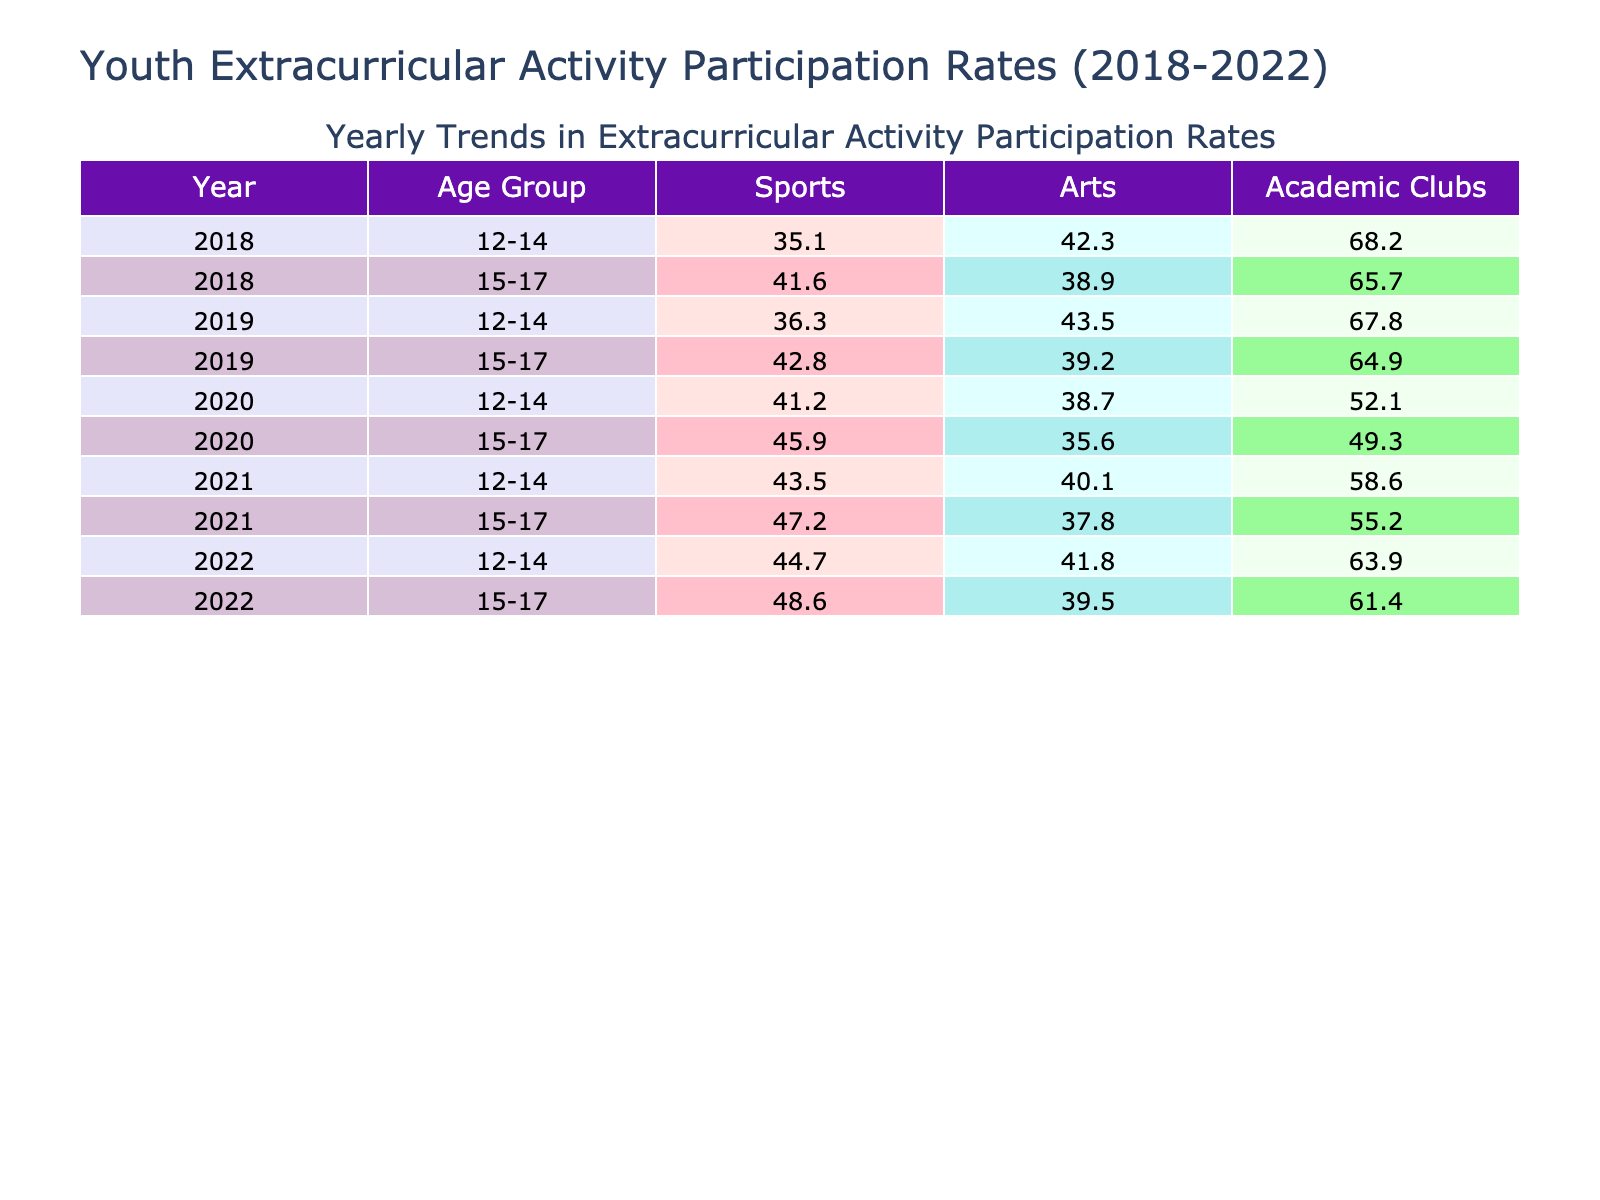What is the participation rate in sports for the age group 12-14 in 2019? In the table, we look for the row where the Year is 2019 and the Age Group is 12-14. The Participation Rate for Sports in that row is 67.8.
Answer: 67.8 What was the highest participation rate for arts among the age group 15-17 during the years 2018 to 2022? To find this, we check the Participation Rates for Arts for the age group 15-17 across all years. The rates are: 38.9 (2018), 39.2 (2019), 35.6 (2020), 37.8 (2021), and 39.5 (2022). The highest value is 39.5 in 2022.
Answer: 39.5 Which activity had the lowest average participation rate for the age group 12-14 across the years? We calculate the average Participation Rates for each activity for the age group 12-14: Sports (66.0), Arts (41.6), and Academic Clubs (38.3). The averages are Sports (66.0), Arts (41.6), Academic Clubs (38.3). The lowest average is for Academic Clubs.
Answer: Academic Clubs Did the participation rate in sports for the age group 15-17 increase from 2020 to 2022? The participation rate in sports for age group 15-17 was 49.3 in 2020 and increased to 61.4 in 2022. Therefore, it did increase between those years.
Answer: Yes Which age group and activity combination had the highest participation rate in 2021? In 2021, we need to find the maximum Participation Rate across all activities and age groups. The rates are: Sports (58.6 for 12-14 and 55.2 for 15-17), Arts (40.1 for 12-14 and 37.8 for 15-17), and Academic Clubs (43.5 for 12-14 and 47.2 for 15-17). The highest is Sports for the age group 12-14 with 58.6.
Answer: Sports for age group 12-14 What was the change in Academic Clubs participation for the age group 15-17 from 2018 to 2022? We check the Participation Rates for Academic Clubs for age group 15-17: in 2018 it was 41.6, and in 2022 it was 48.6. The change is 48.6 - 41.6 = 7.0, indicating an increase of 7.0 percentage points.
Answer: 7.0 Is the participation rate in arts for age group 12-14 higher in 2020 than in 2019? The participation rate for arts age group 12-14 was 43.5 in 2019 and decreased to 38.7 in 2020. Thus, it is not higher in 2020 than in 2019.
Answer: No What is the total participation rate for sports across all age groups in 2022? We sum the Participation Rates for Sports for both age groups 12-14 (63.9) and 15-17 (61.4) in 2022. The total is 63.9 + 61.4 = 125.3.
Answer: 125.3 Was there a decline in the participation rates for arts among the age group 15-17 from 2018 to 2020? The rates for arts age group 15-17 are: 38.9 in 2018, 39.2 in 2019, and 35.6 in 2020. This shows a decline from 38.9 to 35.6, confirming a decrease.
Answer: Yes 